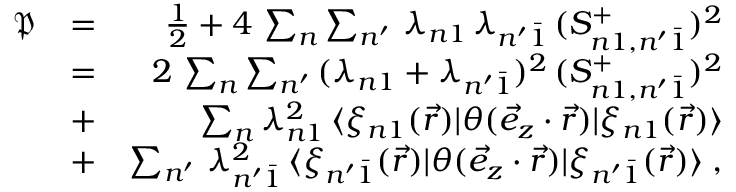<formula> <loc_0><loc_0><loc_500><loc_500>\begin{array} { r l r } { \mathfrak { P } } & { = } & { \frac { 1 } { 2 } + 4 \, \sum _ { n } \sum _ { n ^ { \prime } } \, \lambda _ { n 1 } \, \lambda _ { n ^ { \prime } \bar { 1 } } \, ( S _ { n 1 , n ^ { \prime } \bar { 1 } } ^ { + } ) ^ { 2 } } \\ & { = } & { 2 \, \sum _ { n } \sum _ { n ^ { \prime } } \, ( \lambda _ { n 1 } + \lambda _ { n ^ { \prime } \bar { 1 } } ) ^ { 2 } \, ( S _ { n 1 , n ^ { \prime } \bar { 1 } } ^ { + } ) ^ { 2 } } \\ & { + } & { \sum _ { n } \lambda _ { n 1 } ^ { 2 } \, \langle \xi _ { n 1 } ( \vec { r } ) | \theta ( \vec { e } _ { z } \cdot \vec { r } ) | \xi _ { n 1 } ( \vec { r } ) \rangle } \\ & { + } & { \sum _ { n ^ { \prime } } \, \lambda _ { n ^ { \prime } \bar { 1 } } ^ { 2 } \, \langle \xi _ { n ^ { \prime } \bar { 1 } } ( \vec { r } ) | \theta ( \vec { e } _ { z } \cdot \vec { r } ) | \xi _ { n ^ { \prime } \bar { 1 } } ( \vec { r } ) \rangle \, , } \end{array}</formula> 